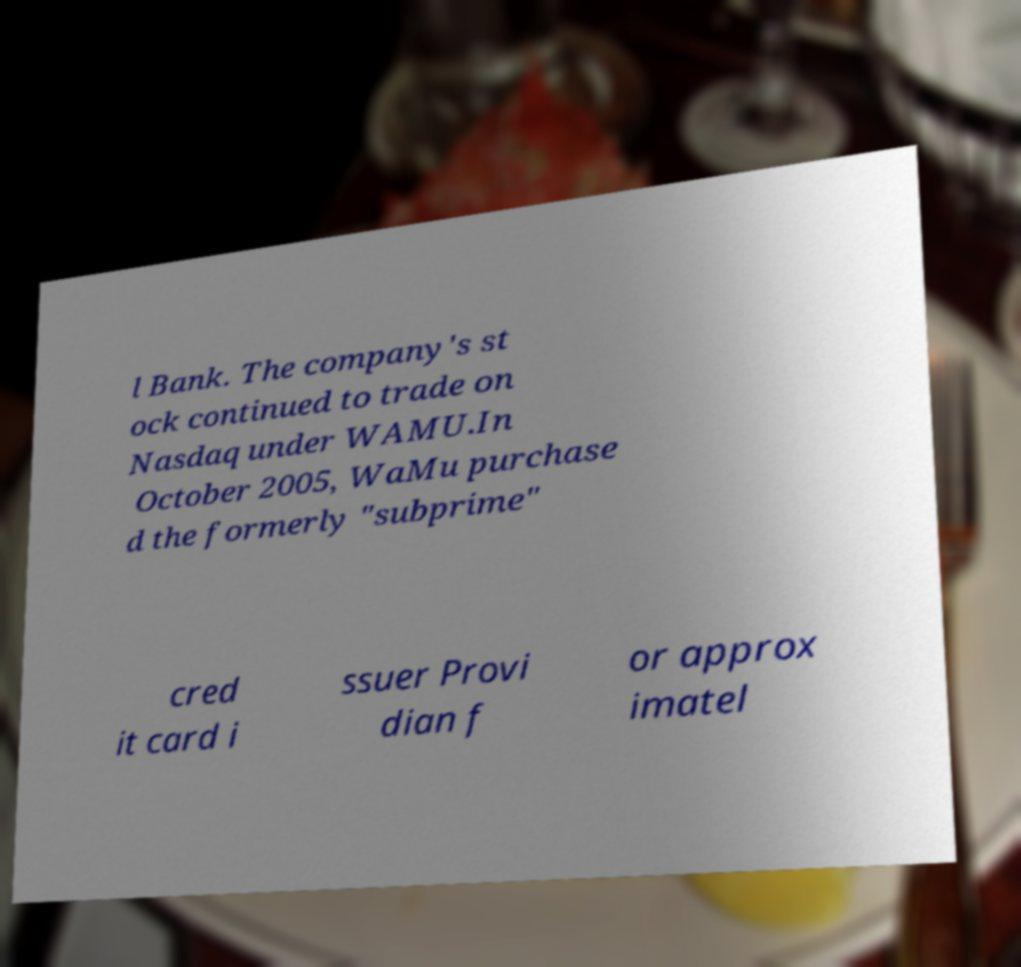Please identify and transcribe the text found in this image. l Bank. The company's st ock continued to trade on Nasdaq under WAMU.In October 2005, WaMu purchase d the formerly "subprime" cred it card i ssuer Provi dian f or approx imatel 